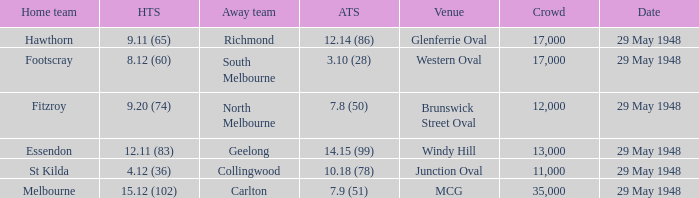In the match where footscray was the home team, how much did they score? 8.12 (60). 